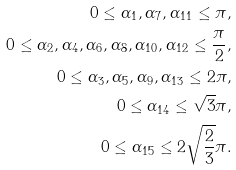Convert formula to latex. <formula><loc_0><loc_0><loc_500><loc_500>0 \leq \alpha _ { 1 } , \alpha _ { 7 } , \alpha _ { 1 1 } \leq \pi , \\ 0 \leq \alpha _ { 2 } , \alpha _ { 4 } , \alpha _ { 6 } , \alpha _ { 8 } , \alpha _ { 1 0 } , \alpha _ { 1 2 } \leq \frac { \pi } { 2 } , \\ 0 \leq \alpha _ { 3 } , \alpha _ { 5 } , \alpha _ { 9 } , \alpha _ { 1 3 } \leq 2 \pi , \\ 0 \leq \alpha _ { 1 4 } \leq \sqrt { 3 } \pi , \\ 0 \leq \alpha _ { 1 5 } \leq 2 \sqrt { \frac { 2 } { 3 } } \pi .</formula> 